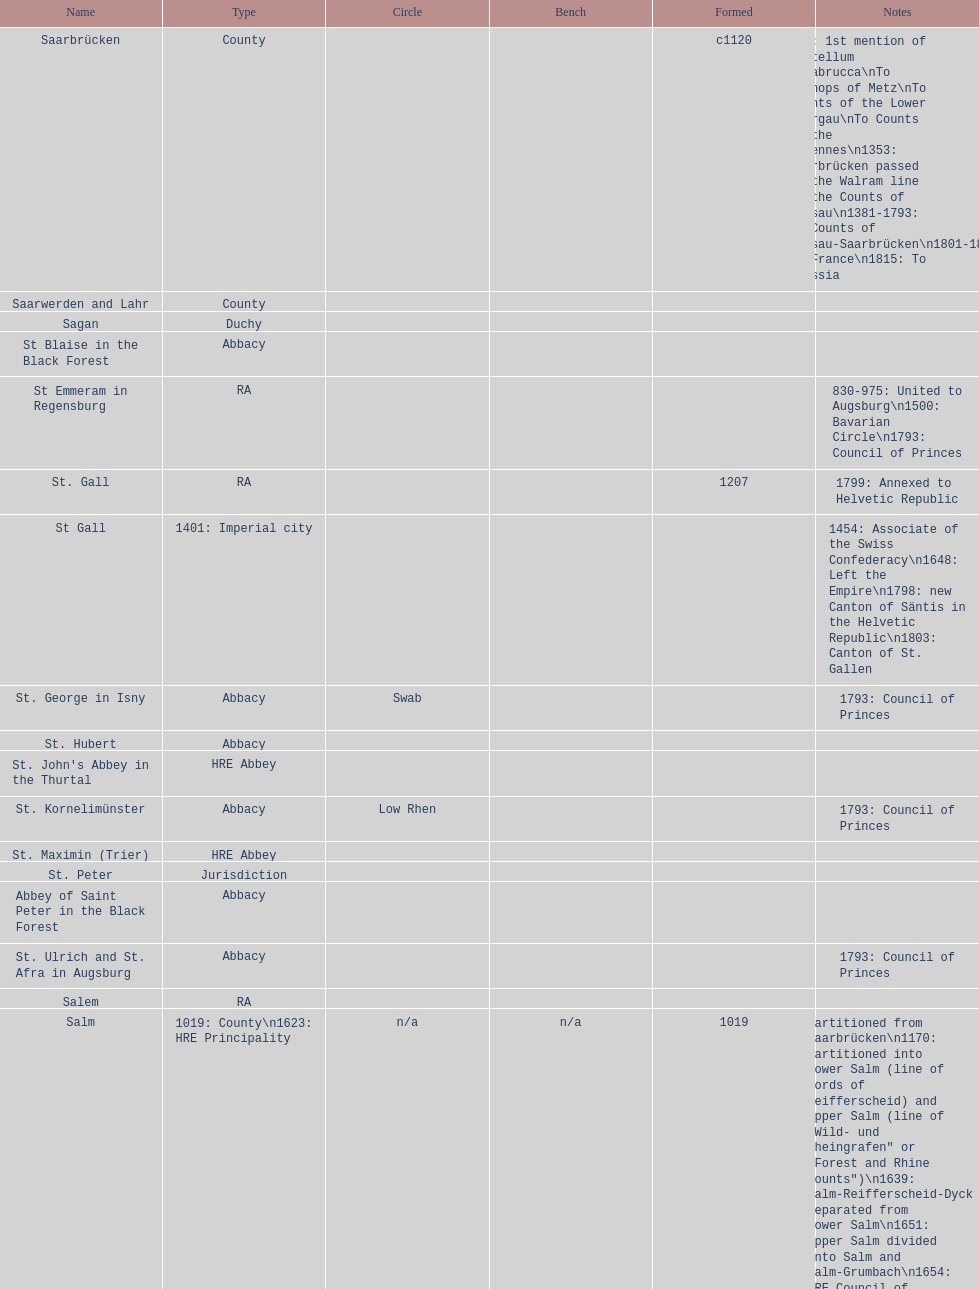What is the status above "sagan"? Saarwerden and Lahr. 